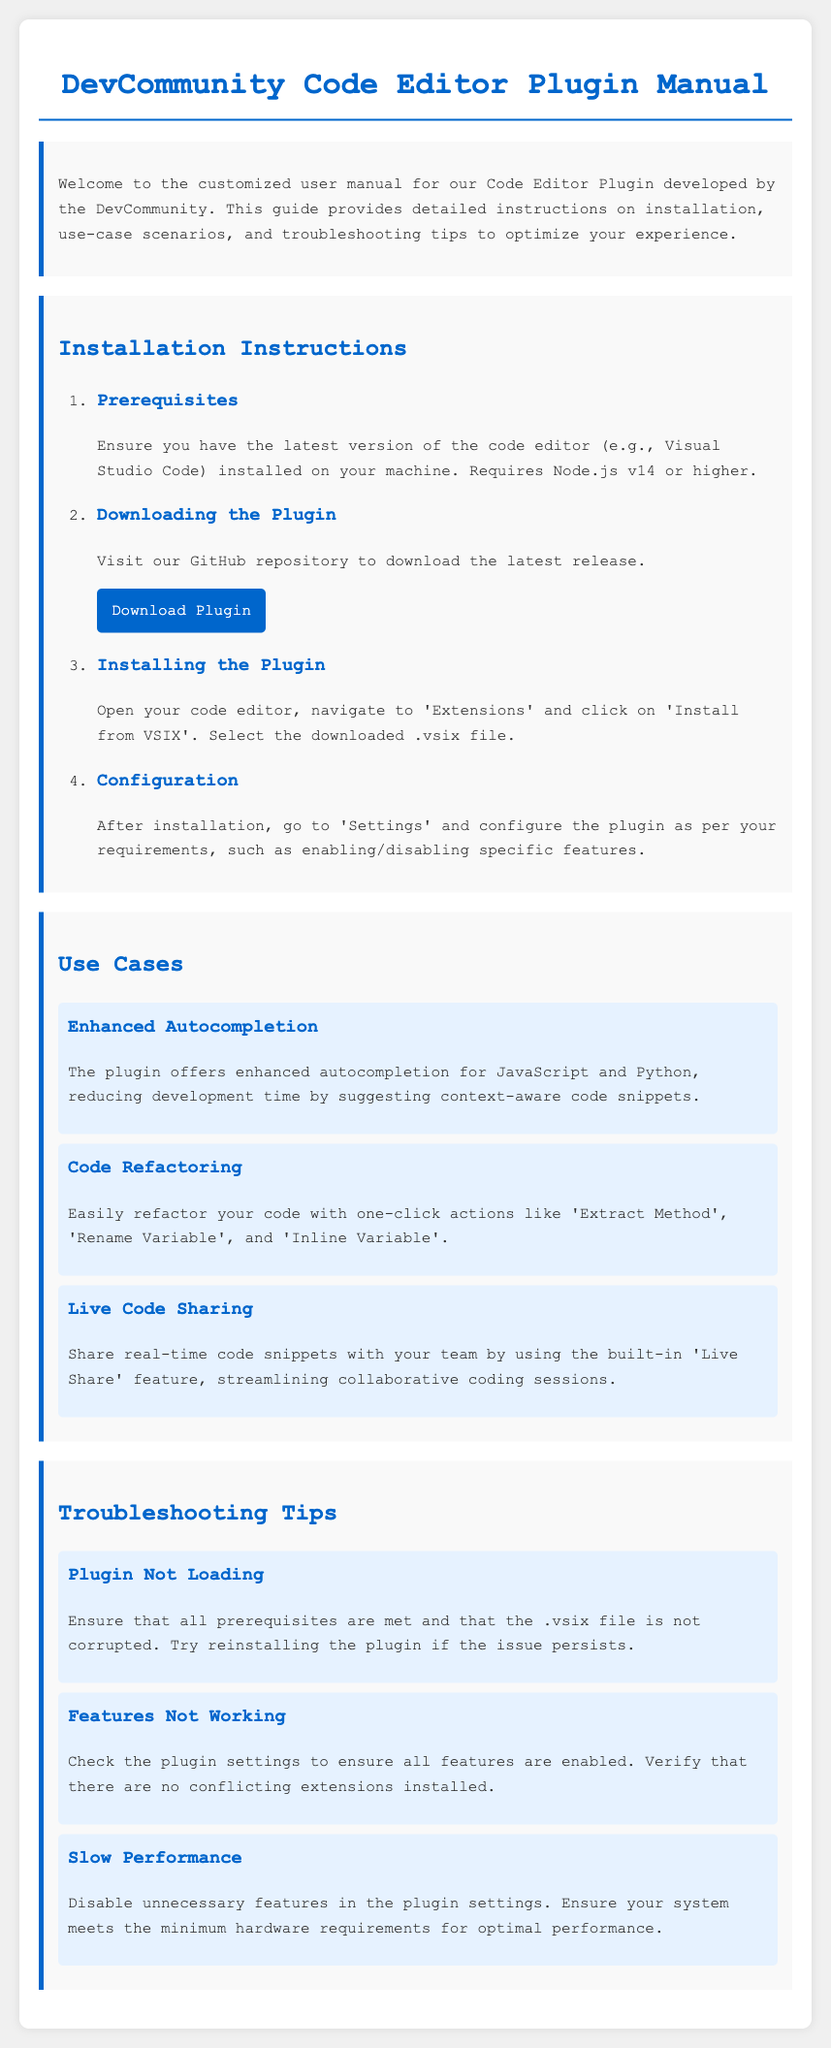What is the title of the manual? The title is mentioned at the top of the document, indicating the subject of the manual.
Answer: DevCommunity Code Editor Plugin Manual What is the required Node.js version? The manual specifies the version of Node.js needed to use the plugin successfully.
Answer: v14 or higher Where can I download the plugin? The document includes a link to a specific location where the plugin can be downloaded.
Answer: GitHub repository What feature does the 'Live Share' function provide? The document explains the purpose of the Live Share feature included in the plugin.
Answer: Real-time code sharing What should you check if the plugin is not loading? This information is located under the troubleshooting tips section and suggests what to verify first.
Answer: Prerequisites How should you configure the plugin after installation? The manual instructs users on what settings to modify after installation for optimal usage.
Answer: Settings What is one-click action available for code refactoring? The manual lists specific actions that can be performed with one click during the refactoring process.
Answer: Extract Method What action is suggested for slow performance? The document provides a recommendation to improve performance if the plugin is slow.
Answer: Disable unnecessary features 